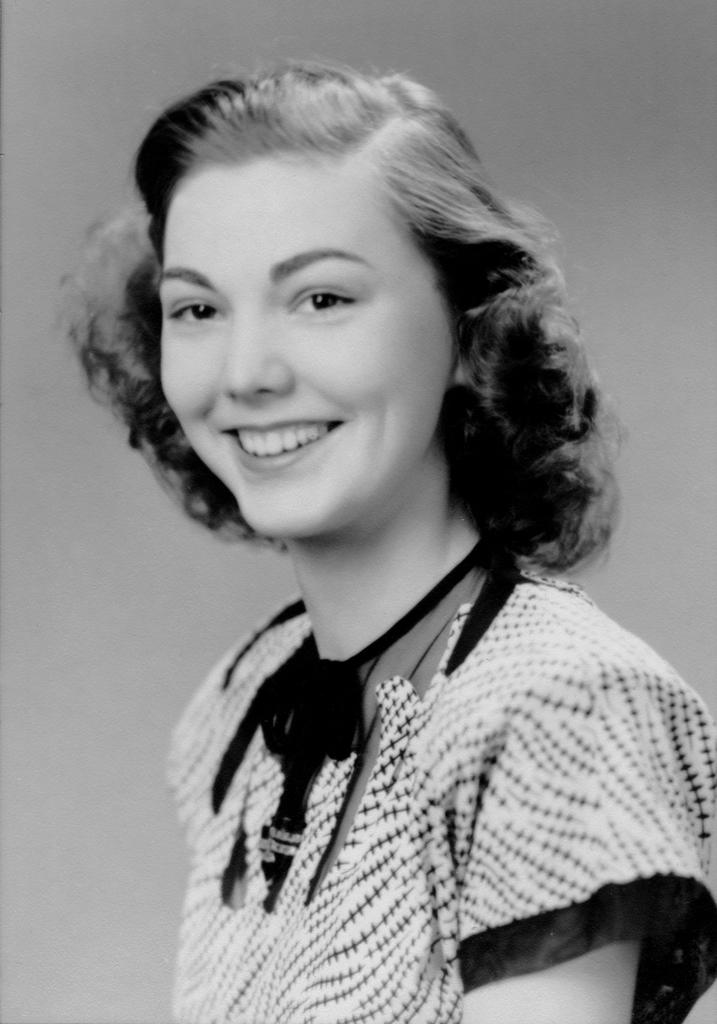Who is in the picture? There is a girl in the picture. What is the girl doing in the picture? The girl is smiling in the picture. What is the color scheme of the picture? The picture is black and white. What can be seen in the background of the picture? There is a plane in the background of the picture. How many ducks are visible in the picture? There are no ducks present in the picture; it features a girl and a plane in the background. Can you describe the snail's shell in the picture? There is no snail present in the picture, so its shell cannot be described. 